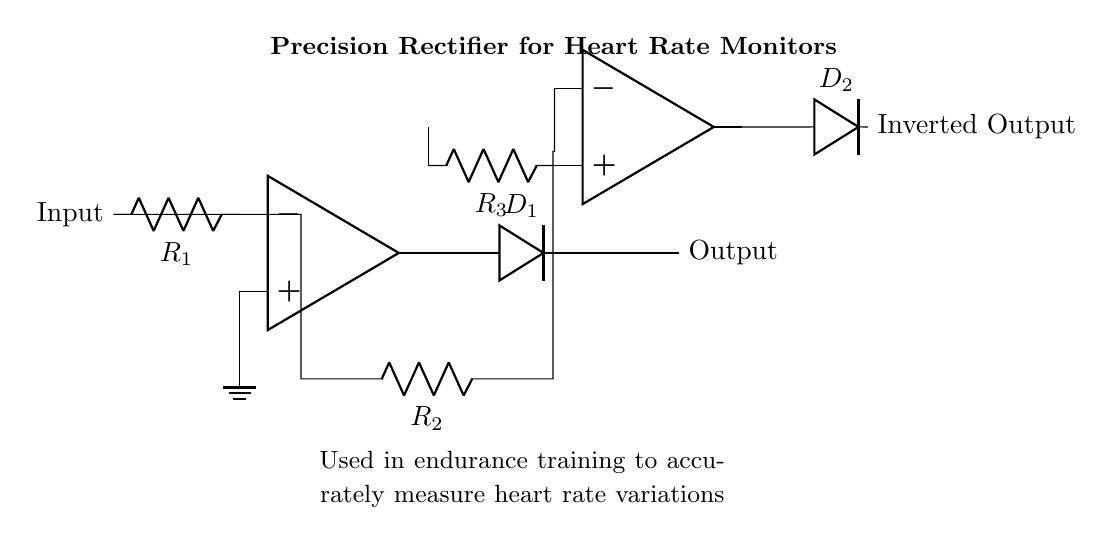What is the type of circuit depicted? The circuit is a precision rectifier, which is specifically designed to provide accurate output even for low-level input signals. This is indicated by the presence of operational amplifiers and diodes in the schematic.
Answer: Precision rectifier How many operational amplifiers are in the circuit? The circuit contains two operational amplifiers, which are used to amplify the input signal and to control the rectification process, as can be seen in the schematic.
Answer: Two What component type is used to rectify the signal? The circuit uses diodes for rectification, as indicated by the labels on the components. They allow current to flow in one direction, effectively converting AC signals to DC.
Answer: Diode What is the feedback component connected to the second operational amplifier? The feedback component connected to the second operational amplifier is a resistor, which plays a crucial role in stabilizing the gain of the op-amp, as indicated in the schematic.
Answer: Resistor What is the purpose of this precision rectifier circuit in heart rate monitors? The specific purpose of this precision rectifier circuit is to measure heart rate variations accurately, which is essential in endurance training performance analysis, as described in the annotations on the circuit.
Answer: Measure heart rate variations What would happen if the diodes were reversed? If the diodes were reversed, the circuit would not function correctly as a rectifier; it would block the intended current flow and not provide the necessary output signal for heart rate monitoring, which is fundamentally important for precise measurement.
Answer: Incorrect rectification 